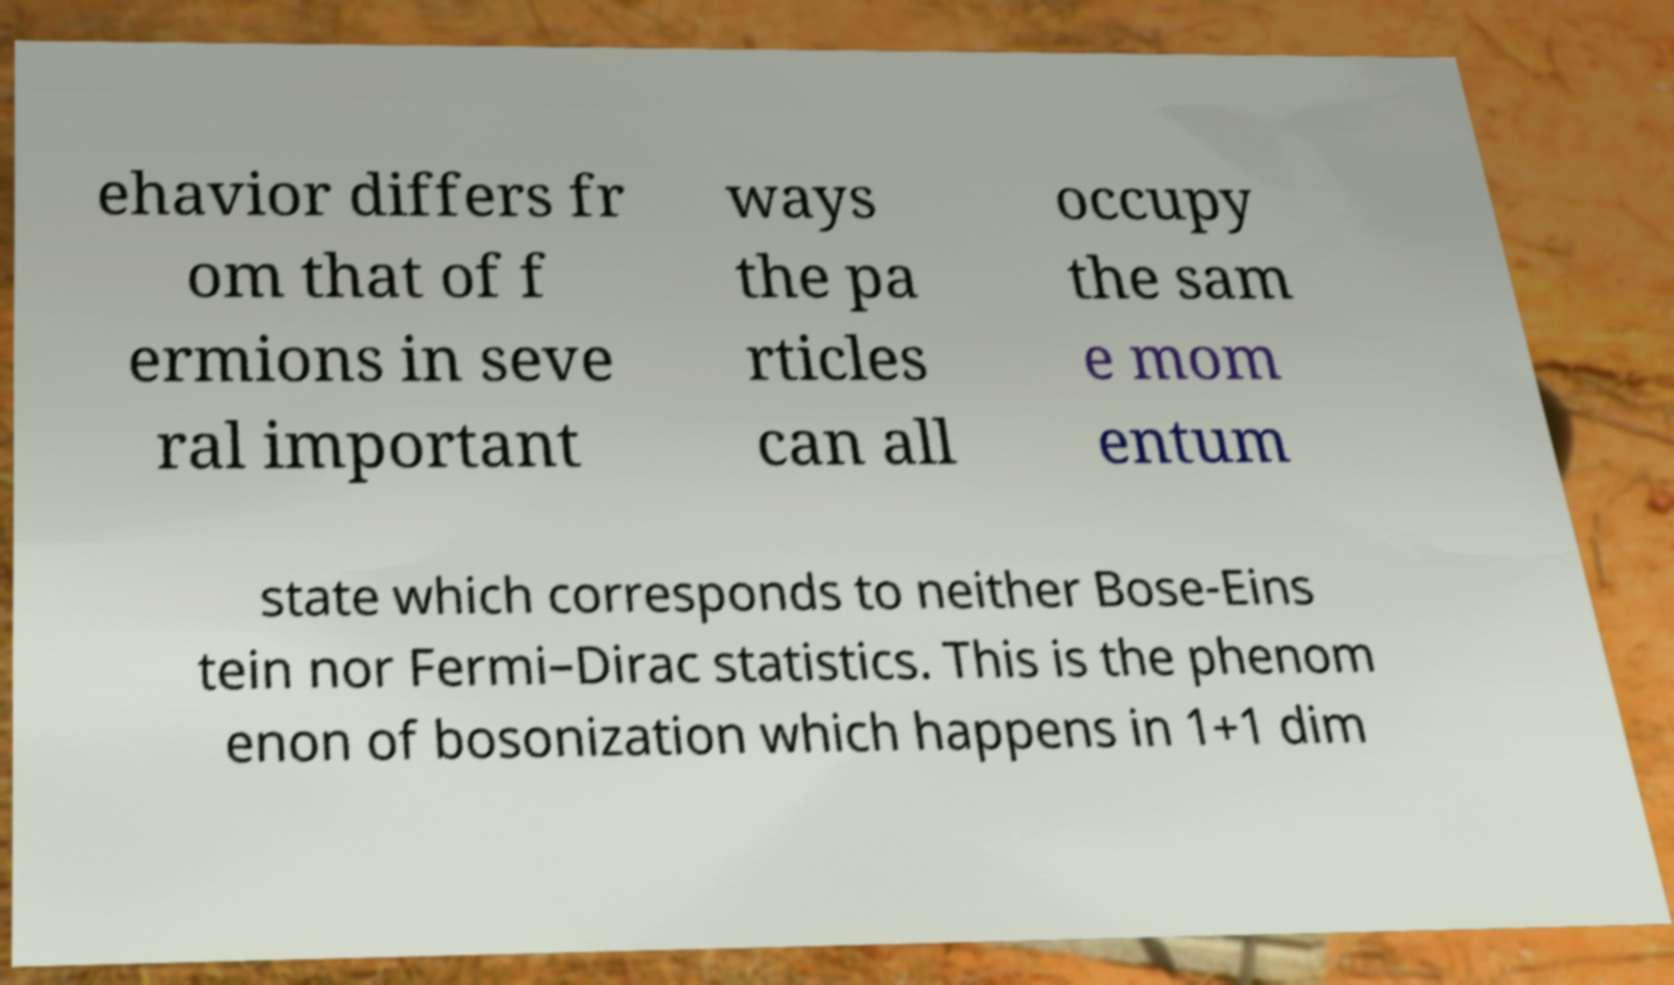There's text embedded in this image that I need extracted. Can you transcribe it verbatim? ehavior differs fr om that of f ermions in seve ral important ways the pa rticles can all occupy the sam e mom entum state which corresponds to neither Bose-Eins tein nor Fermi–Dirac statistics. This is the phenom enon of bosonization which happens in 1+1 dim 